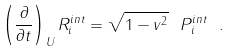<formula> <loc_0><loc_0><loc_500><loc_500>\left ( \frac { \partial } { \partial t } \right ) _ { U } R ^ { i n t } _ { i } = \sqrt { 1 - { v } ^ { 2 } } \ P ^ { i n t } _ { i } \ .</formula> 